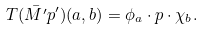<formula> <loc_0><loc_0><loc_500><loc_500>T ( \bar { M ^ { \prime } } p ^ { \prime } ) ( a , b ) = \phi _ { a } \cdot p \cdot \chi _ { b } .</formula> 